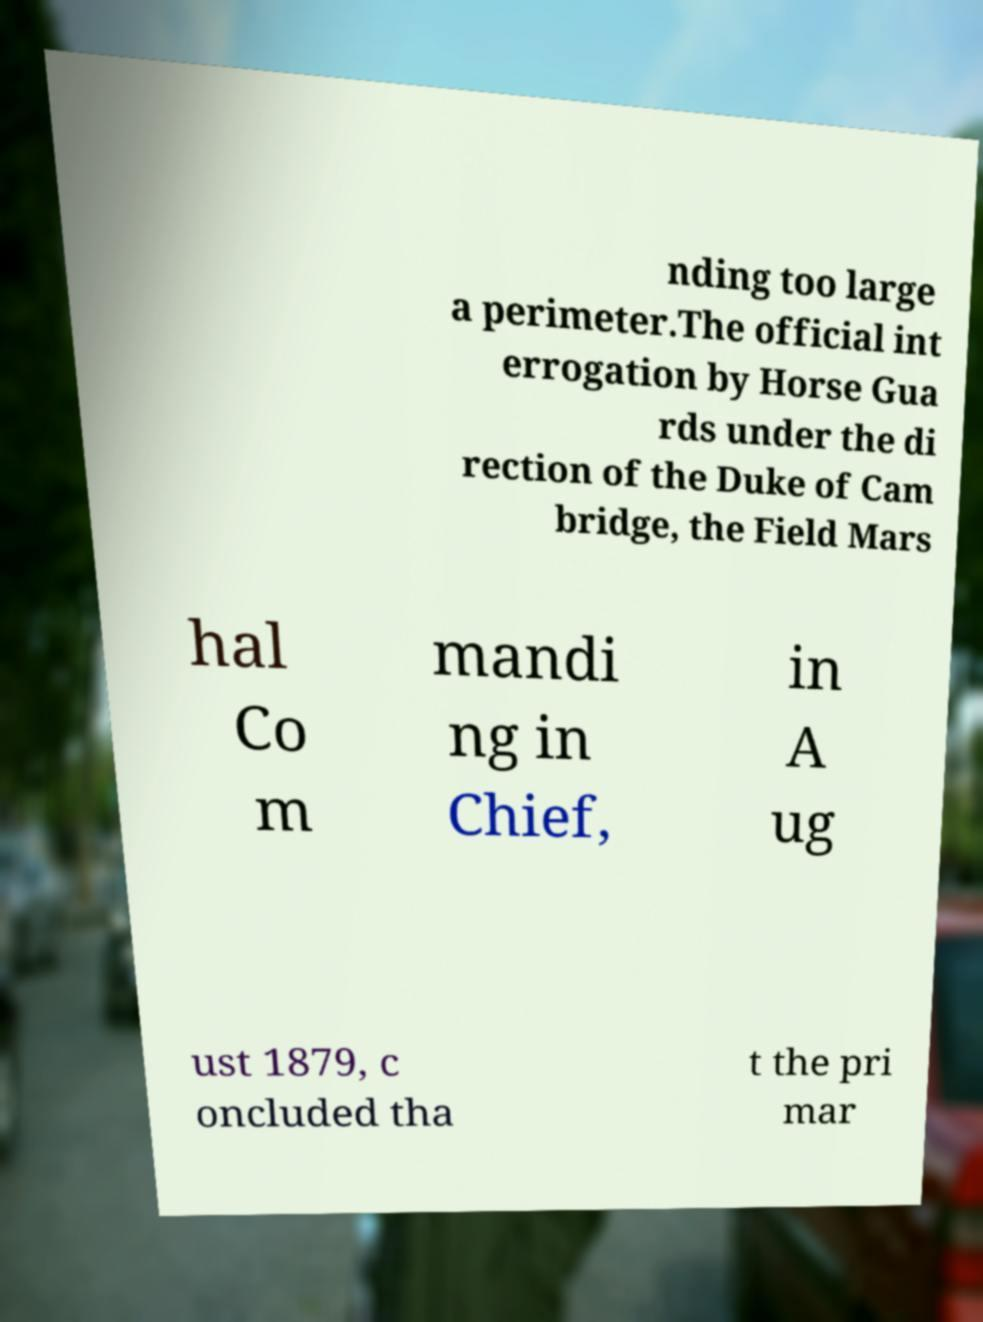Please identify and transcribe the text found in this image. nding too large a perimeter.The official int errogation by Horse Gua rds under the di rection of the Duke of Cam bridge, the Field Mars hal Co m mandi ng in Chief, in A ug ust 1879, c oncluded tha t the pri mar 